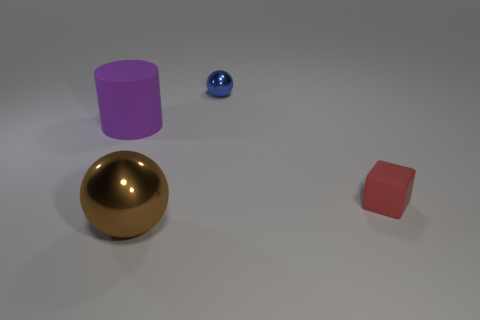Add 4 large metal spheres. How many objects exist? 8 Subtract all cylinders. How many objects are left? 3 Subtract 0 cyan cubes. How many objects are left? 4 Subtract all large yellow things. Subtract all rubber objects. How many objects are left? 2 Add 1 tiny blue objects. How many tiny blue objects are left? 2 Add 4 red objects. How many red objects exist? 5 